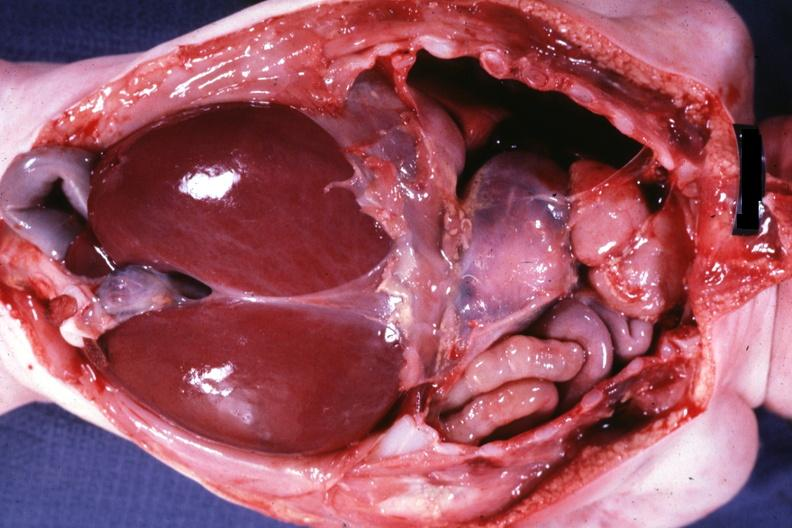s soft tissue present?
Answer the question using a single word or phrase. Yes 